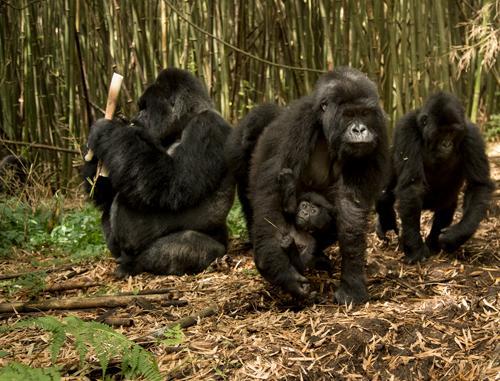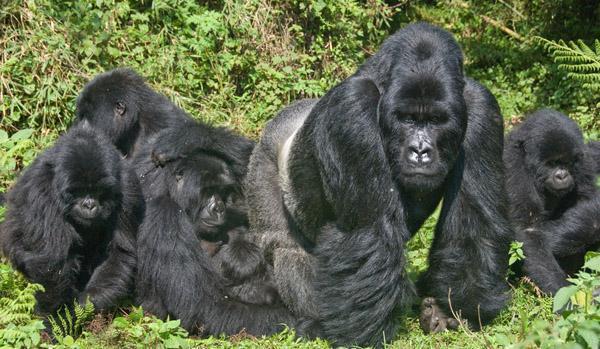The first image is the image on the left, the second image is the image on the right. Assess this claim about the two images: "The right image contains no more than three gorillas and includes a furry young gorilla, and the left image shows a close family group of gorillas facing forward.". Correct or not? Answer yes or no. No. The first image is the image on the left, the second image is the image on the right. Assess this claim about the two images: "There are no more than six gorillas in total.". Correct or not? Answer yes or no. No. 